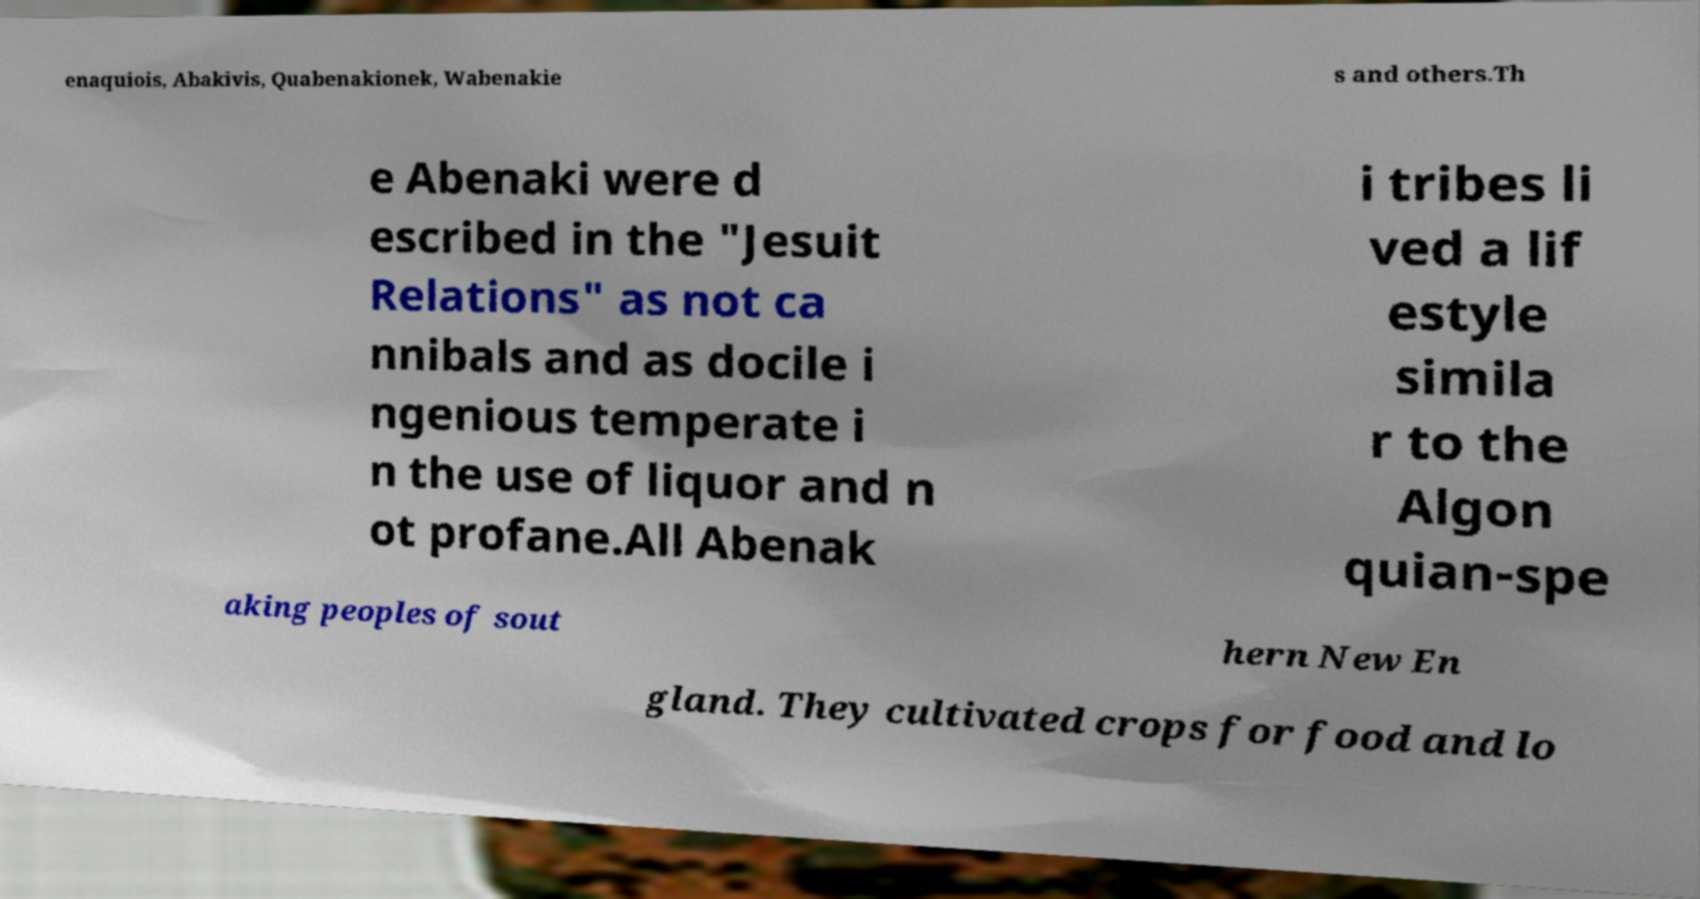I need the written content from this picture converted into text. Can you do that? enaquiois, Abakivis, Quabenakionek, Wabenakie s and others.Th e Abenaki were d escribed in the "Jesuit Relations" as not ca nnibals and as docile i ngenious temperate i n the use of liquor and n ot profane.All Abenak i tribes li ved a lif estyle simila r to the Algon quian-spe aking peoples of sout hern New En gland. They cultivated crops for food and lo 